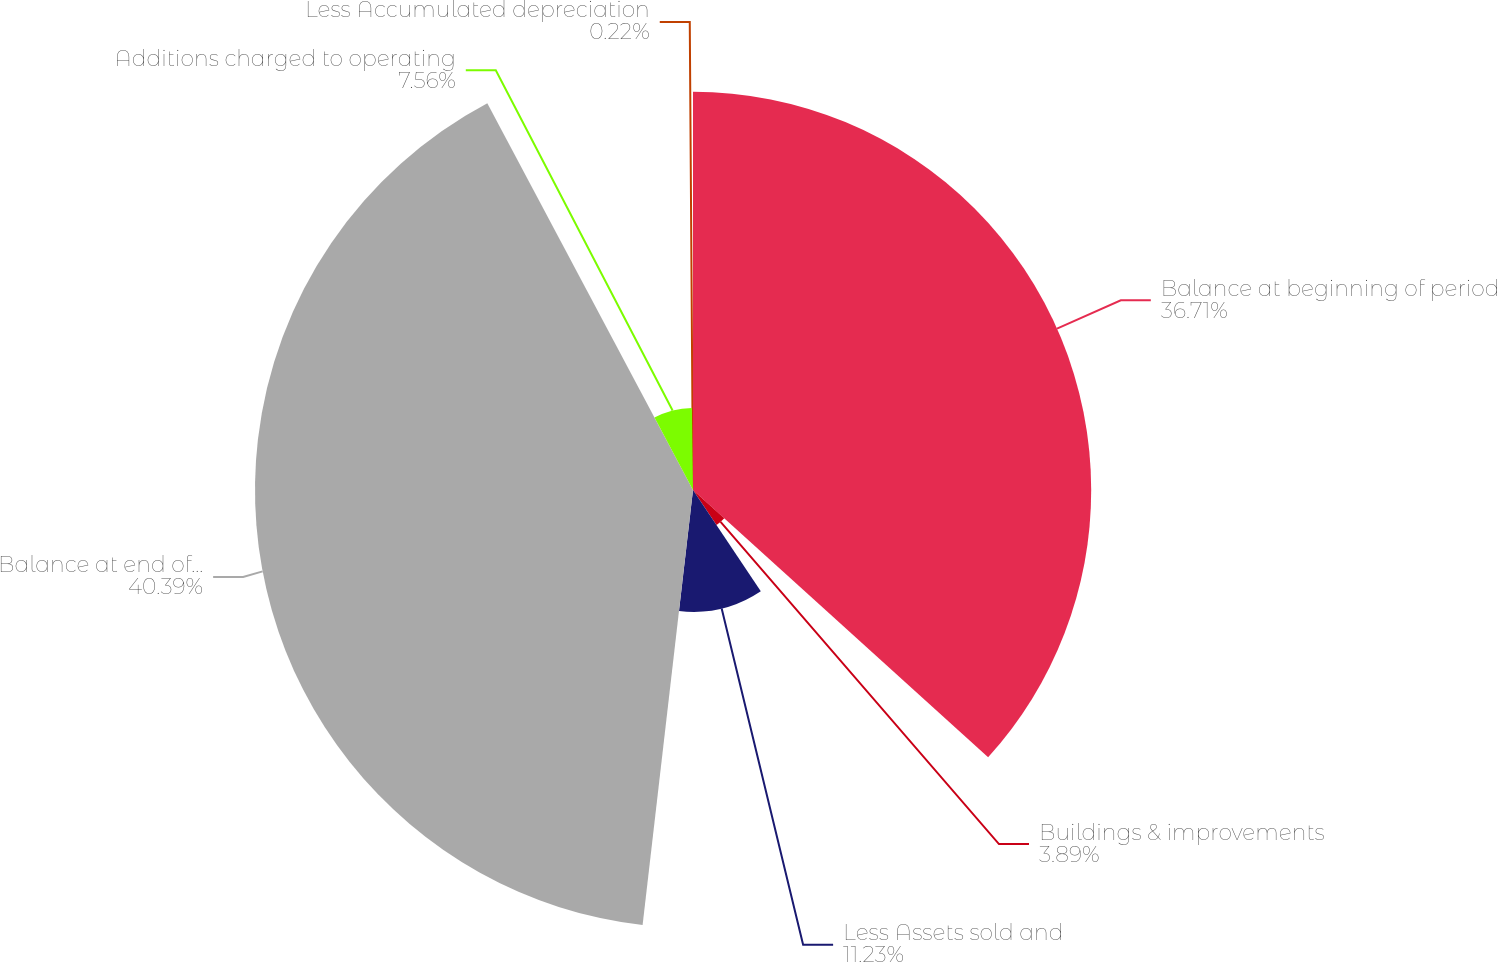<chart> <loc_0><loc_0><loc_500><loc_500><pie_chart><fcel>Balance at beginning of period<fcel>Buildings & improvements<fcel>Less Assets sold and<fcel>Balance at end of period<fcel>Additions charged to operating<fcel>Less Accumulated depreciation<nl><fcel>36.71%<fcel>3.89%<fcel>11.23%<fcel>40.38%<fcel>7.56%<fcel>0.22%<nl></chart> 